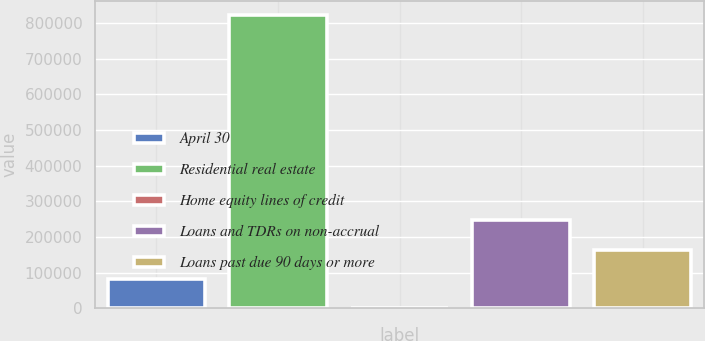Convert chart to OTSL. <chart><loc_0><loc_0><loc_500><loc_500><bar_chart><fcel>April 30<fcel>Residential real estate<fcel>Home equity lines of credit<fcel>Loans and TDRs on non-accrual<fcel>Loans past due 90 days or more<nl><fcel>82386.9<fcel>821583<fcel>254<fcel>246653<fcel>164520<nl></chart> 